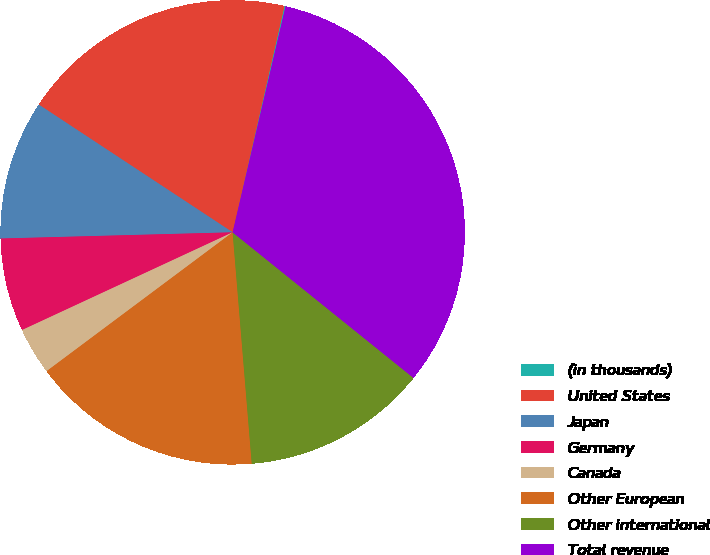Convert chart. <chart><loc_0><loc_0><loc_500><loc_500><pie_chart><fcel>(in thousands)<fcel>United States<fcel>Japan<fcel>Germany<fcel>Canada<fcel>Other European<fcel>Other international<fcel>Total revenue<nl><fcel>0.08%<fcel>19.31%<fcel>9.7%<fcel>6.49%<fcel>3.29%<fcel>16.11%<fcel>12.9%<fcel>32.13%<nl></chart> 